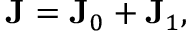<formula> <loc_0><loc_0><loc_500><loc_500>{ J } = { J } _ { 0 } + { J } _ { 1 } ,</formula> 